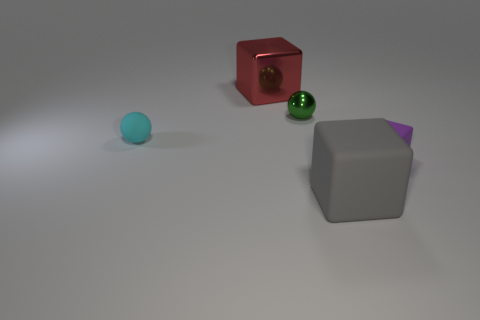Add 2 big things. How many objects exist? 7 Subtract all spheres. How many objects are left? 3 Add 1 large gray matte cubes. How many large gray matte cubes are left? 2 Add 2 gray cubes. How many gray cubes exist? 3 Subtract 0 purple balls. How many objects are left? 5 Subtract all gray matte things. Subtract all tiny blue metal balls. How many objects are left? 4 